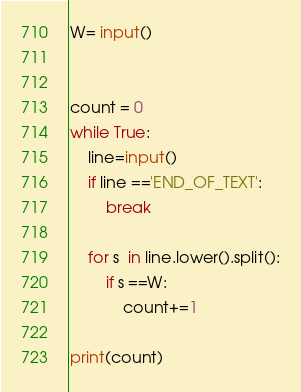Convert code to text. <code><loc_0><loc_0><loc_500><loc_500><_Python_>W= input()


count = 0
while True:
    line=input()
    if line =='END_OF_TEXT':
        break
      
    for s  in line.lower().split():
        if s ==W:
            count+=1

print(count)</code> 